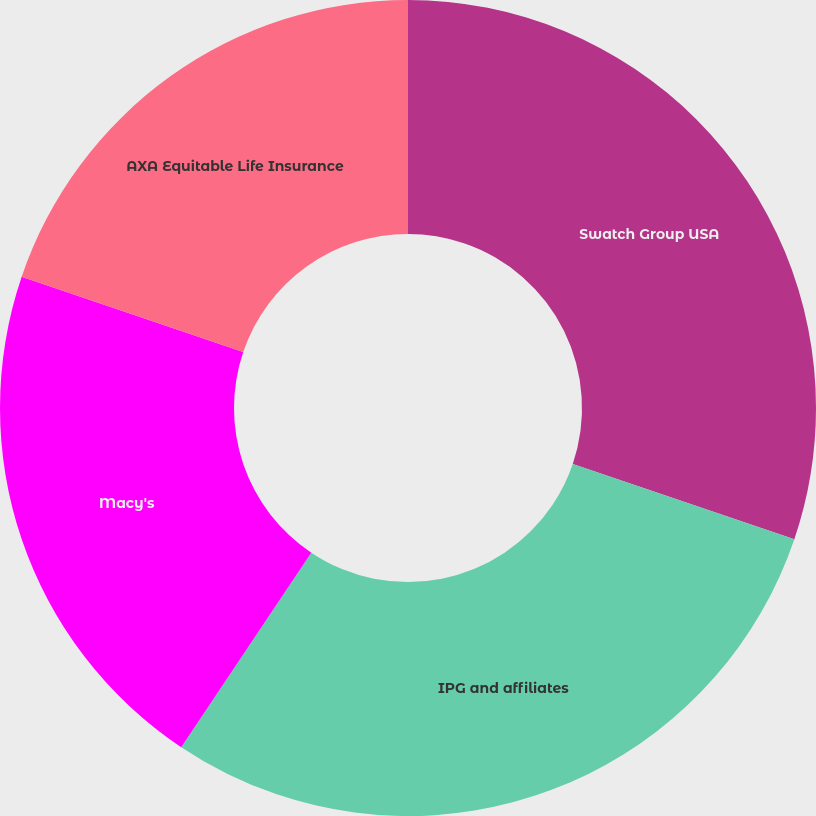Convert chart to OTSL. <chart><loc_0><loc_0><loc_500><loc_500><pie_chart><fcel>Swatch Group USA<fcel>IPG and affiliates<fcel>Macy's<fcel>AXA Equitable Life Insurance<nl><fcel>30.21%<fcel>29.17%<fcel>20.83%<fcel>19.79%<nl></chart> 